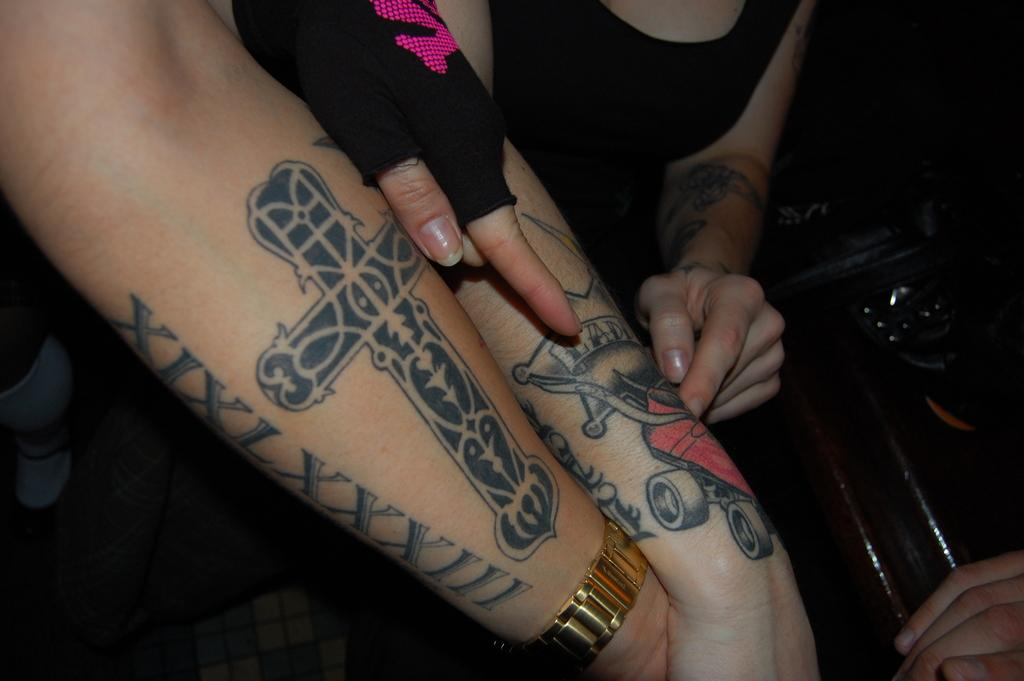What can be seen in the image involving the hands? There are two hands in the image, and they have tattoos. What accessory is present on one of the hands? There is a watch on one of the hands. What type of hook can be seen on the hand in the image? There is no hook present on the hand in the image. What is the butter doing in the image? There is no butter present in the image. 